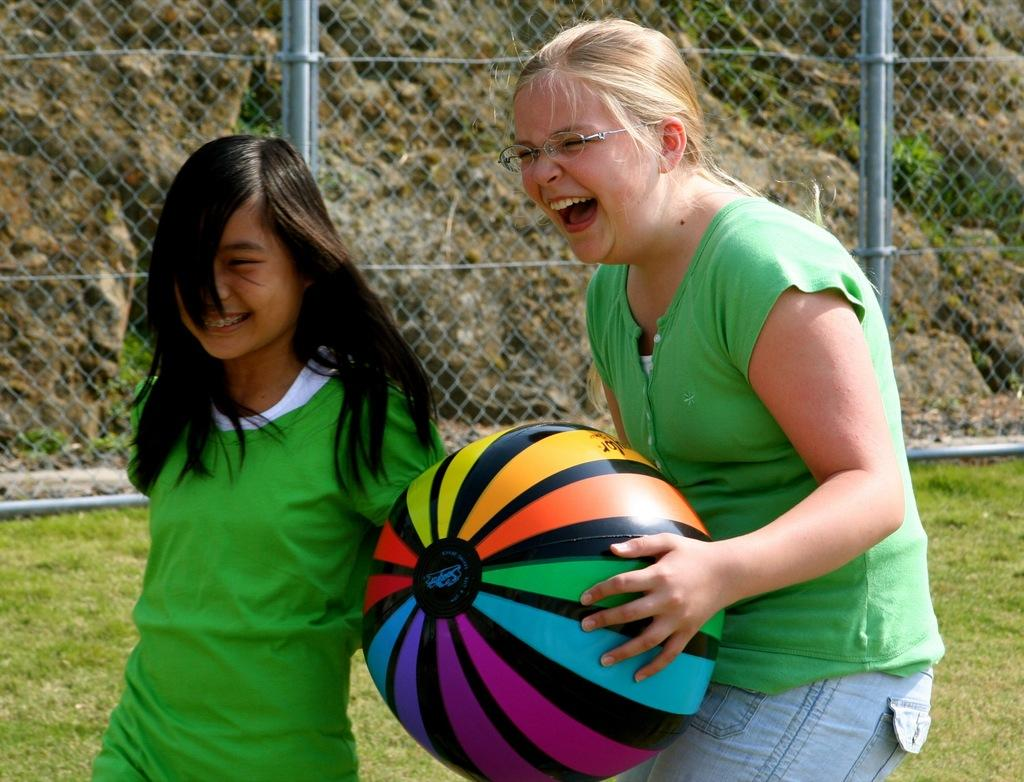How many girls are in the image? There are two girls in the image. What are the girls doing in the image? The girls are standing and smiling in the image. What object is one of the girls holding? One girl is holding a ball in the image. What type of surface can be seen in the image? There is grass in the image. What type of barrier is present in the image? There is a wire fence in the image. What can be seen in the background of the image? There are rocks and plants in the background of the image. Where is the furniture located in the image? There is no furniture present in the image. How many icicles can be seen hanging from the wire fence in the image? There are no icicles present in the image. 